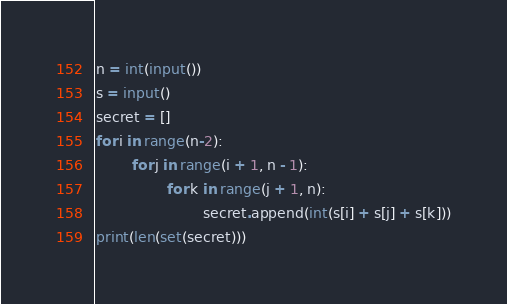Convert code to text. <code><loc_0><loc_0><loc_500><loc_500><_Python_>n = int(input())
s = input()
secret = []
for i in range(n-2):
        for j in range(i + 1, n - 1): 
                for k in range(j + 1, n): 
                        secret.append(int(s[i] + s[j] + s[k]))
print(len(set(secret)))</code> 